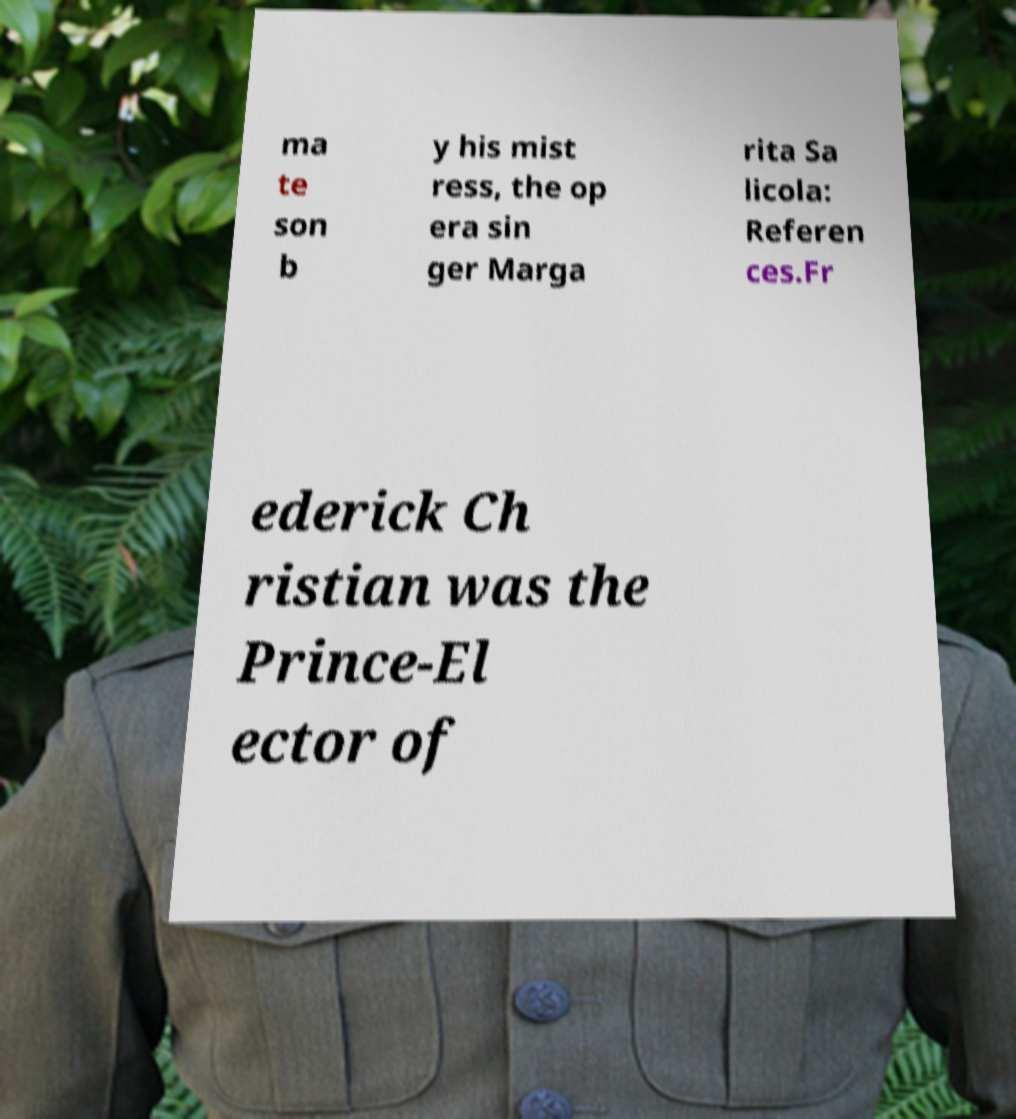Please read and relay the text visible in this image. What does it say? ma te son b y his mist ress, the op era sin ger Marga rita Sa licola: Referen ces.Fr ederick Ch ristian was the Prince-El ector of 